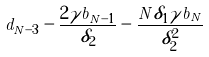<formula> <loc_0><loc_0><loc_500><loc_500>d _ { N - 3 } - \frac { 2 \gamma b _ { N - 1 } } { \delta _ { 2 } } - \frac { N \delta _ { 1 } \gamma b _ { N } } { \delta _ { 2 } ^ { 2 } }</formula> 